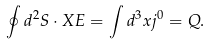Convert formula to latex. <formula><loc_0><loc_0><loc_500><loc_500>\oint d ^ { 2 } { S } \cdot X { E } = \int d ^ { 3 } x j ^ { 0 } = Q .</formula> 